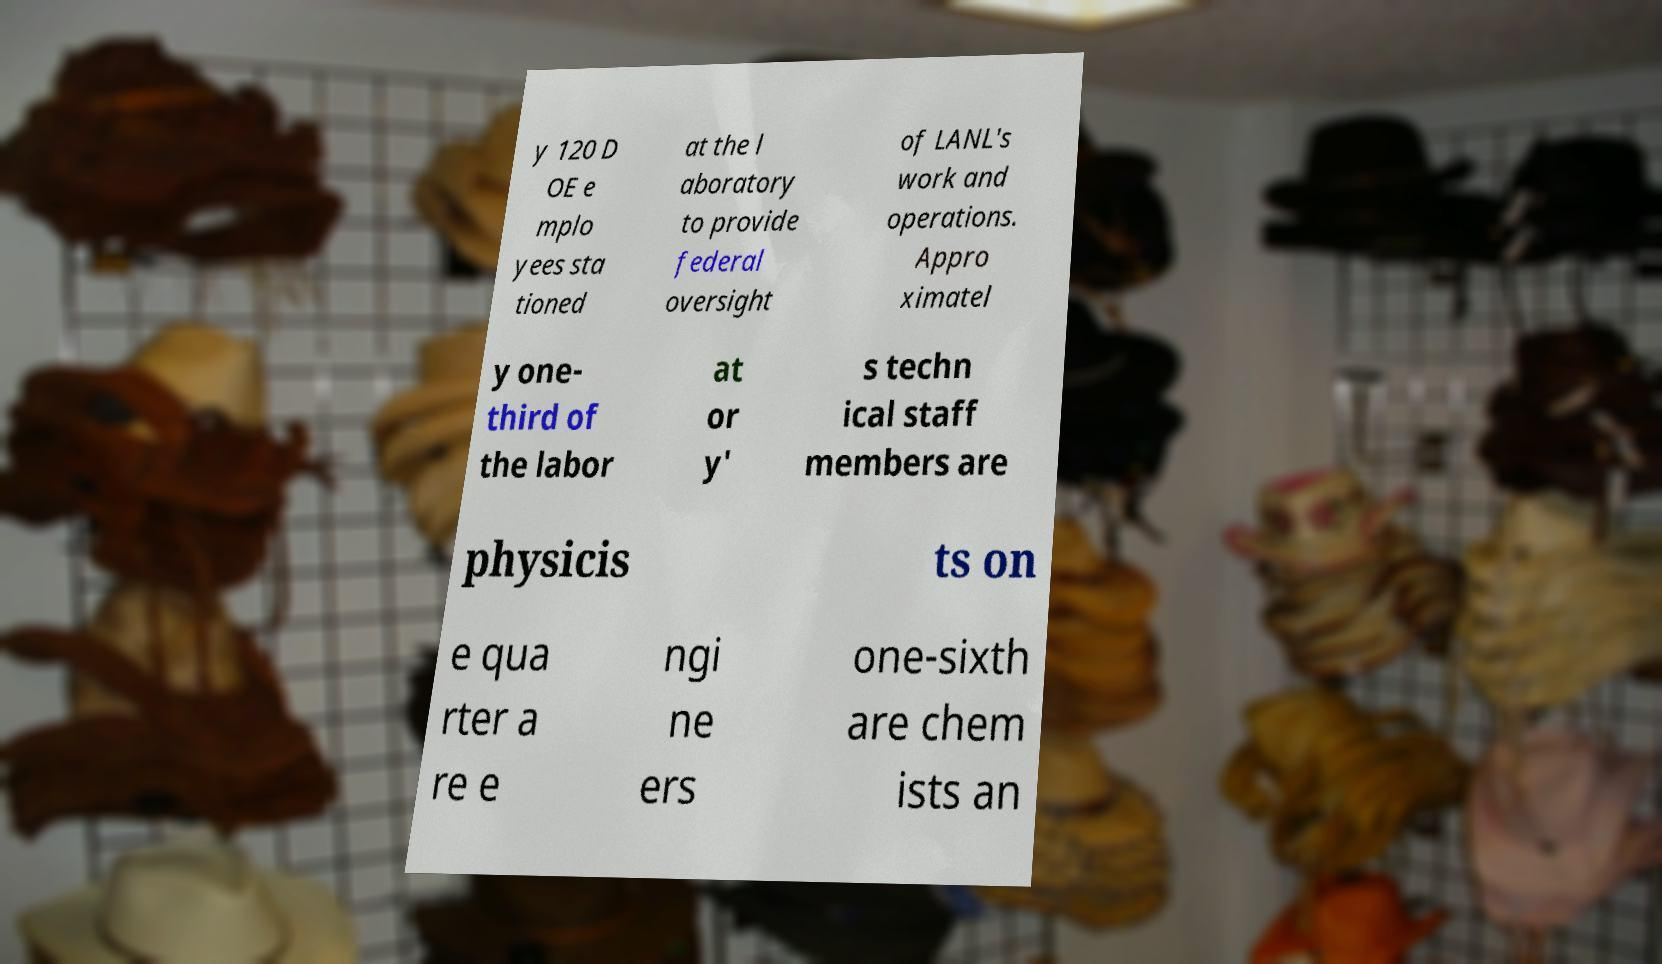Could you assist in decoding the text presented in this image and type it out clearly? y 120 D OE e mplo yees sta tioned at the l aboratory to provide federal oversight of LANL's work and operations. Appro ximatel y one- third of the labor at or y' s techn ical staff members are physicis ts on e qua rter a re e ngi ne ers one-sixth are chem ists an 